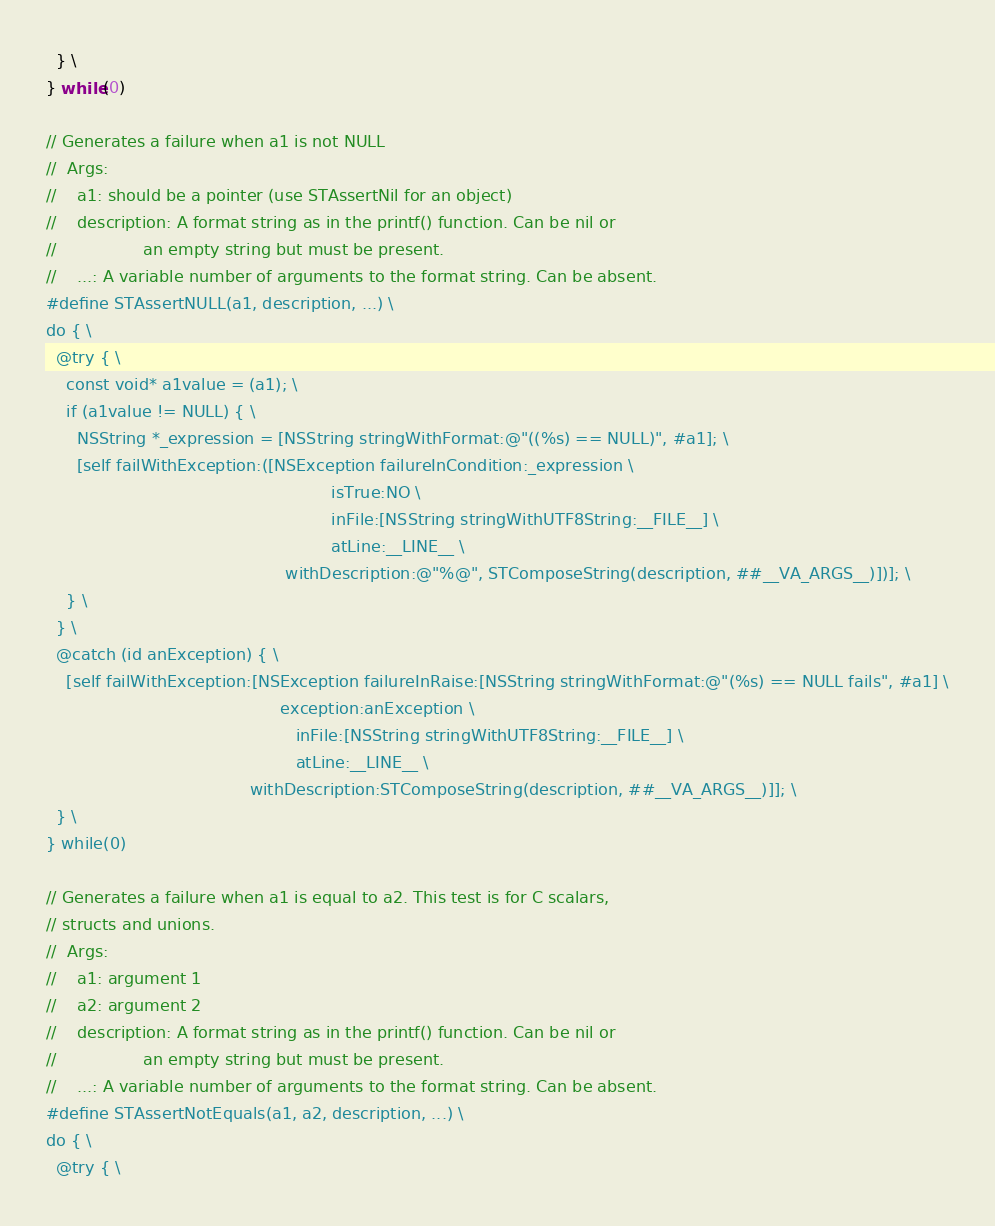Convert code to text. <code><loc_0><loc_0><loc_500><loc_500><_C_>  } \
} while(0)

// Generates a failure when a1 is not NULL
//  Args:
//    a1: should be a pointer (use STAssertNil for an object)
//    description: A format string as in the printf() function. Can be nil or
//                 an empty string but must be present.
//    ...: A variable number of arguments to the format string. Can be absent.
#define STAssertNULL(a1, description, ...) \
do { \
  @try { \
    const void* a1value = (a1); \
    if (a1value != NULL) { \
      NSString *_expression = [NSString stringWithFormat:@"((%s) == NULL)", #a1]; \
      [self failWithException:([NSException failureInCondition:_expression \
                                                        isTrue:NO \
                                                        inFile:[NSString stringWithUTF8String:__FILE__] \
                                                        atLine:__LINE__ \
                                               withDescription:@"%@", STComposeString(description, ##__VA_ARGS__)])]; \
    } \
  } \
  @catch (id anException) { \
    [self failWithException:[NSException failureInRaise:[NSString stringWithFormat:@"(%s) == NULL fails", #a1] \
                                              exception:anException \
                                                 inFile:[NSString stringWithUTF8String:__FILE__] \
                                                 atLine:__LINE__ \
                                        withDescription:STComposeString(description, ##__VA_ARGS__)]]; \
  } \
} while(0)

// Generates a failure when a1 is equal to a2. This test is for C scalars, 
// structs and unions.
//  Args:
//    a1: argument 1
//    a2: argument 2
//    description: A format string as in the printf() function. Can be nil or
//                 an empty string but must be present.
//    ...: A variable number of arguments to the format string. Can be absent.
#define STAssertNotEquals(a1, a2, description, ...) \
do { \
  @try { \</code> 